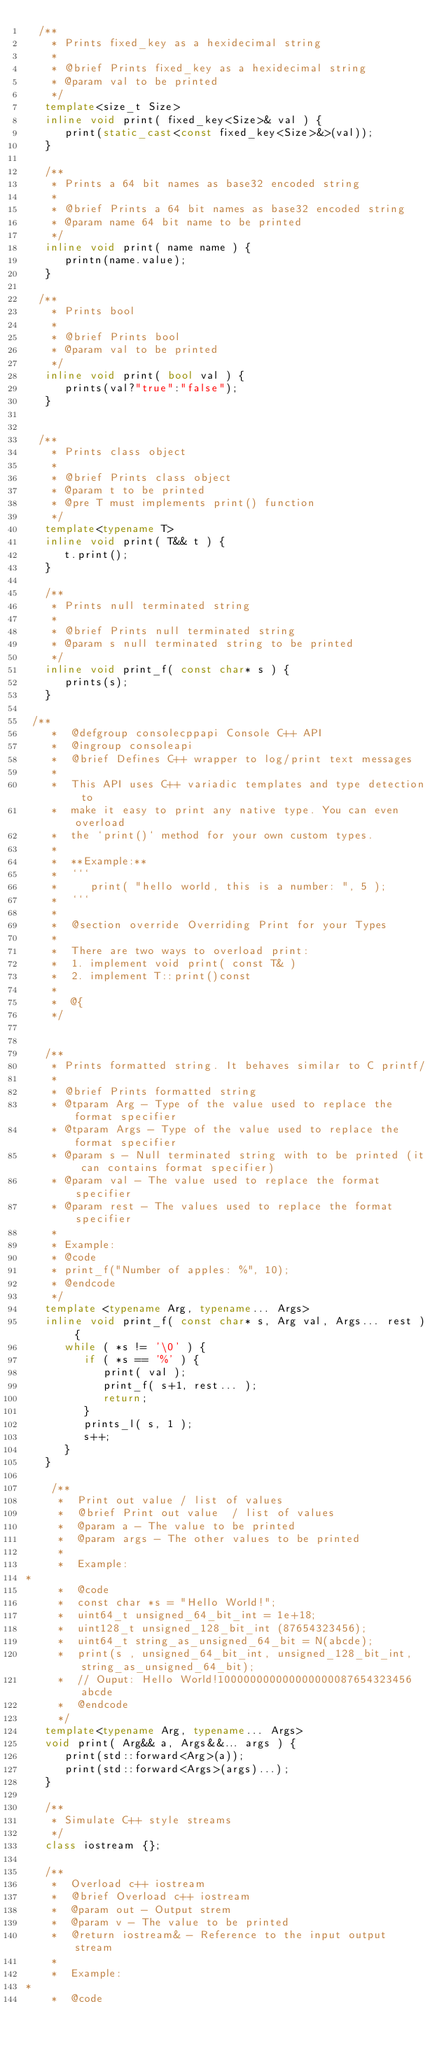Convert code to text. <code><loc_0><loc_0><loc_500><loc_500><_C++_>  /**
    * Prints fixed_key as a hexidecimal string
    * 
    * @brief Prints fixed_key as a hexidecimal string
    * @param val to be printed
    */
   template<size_t Size>
   inline void print( fixed_key<Size>& val ) {
      print(static_cast<const fixed_key<Size>&>(val));
   }

   /**
    * Prints a 64 bit names as base32 encoded string
    * 
    * @brief Prints a 64 bit names as base32 encoded string
    * @param name 64 bit name to be printed
    */
   inline void print( name name ) {
      printn(name.value);
   }

  /**
    * Prints bool
    * 
    * @brief Prints bool
    * @param val to be printed
    */
   inline void print( bool val ) {
      prints(val?"true":"false");
   }


  /**
    * Prints class object
    * 
    * @brief Prints class object
    * @param t to be printed
    * @pre T must implements print() function
    */
   template<typename T>
   inline void print( T&& t ) {
      t.print();
   }

   /**
    * Prints null terminated string
    * 
    * @brief Prints null terminated string
    * @param s null terminated string to be printed
    */
   inline void print_f( const char* s ) {
      prints(s);
   }

 /**
    *  @defgroup consolecppapi Console C++ API
    *  @ingroup consoleapi
    *  @brief Defines C++ wrapper to log/print text messages
    *
    *  This API uses C++ variadic templates and type detection to
    *  make it easy to print any native type. You can even overload
    *  the `print()` method for your own custom types.
    *
    *  **Example:**
    *  ```
    *     print( "hello world, this is a number: ", 5 );
    *  ```
    *
    *  @section override Overriding Print for your Types
    *
    *  There are two ways to overload print:
    *  1. implement void print( const T& )
    *  2. implement T::print()const
    *
    *  @{
    */


   /**
    * Prints formatted string. It behaves similar to C printf/
    * 
    * @brief Prints formatted string
    * @tparam Arg - Type of the value used to replace the format specifier
    * @tparam Args - Type of the value used to replace the format specifier
    * @param s - Null terminated string with to be printed (it can contains format specifier)
    * @param val - The value used to replace the format specifier
    * @param rest - The values used to replace the format specifier
    * 
    * Example:
    * @code
    * print_f("Number of apples: %", 10);
    * @endcode
    */
   template <typename Arg, typename... Args>
   inline void print_f( const char* s, Arg val, Args... rest ) {
      while ( *s != '\0' ) {
         if ( *s == '%' ) {
            print( val );
            print_f( s+1, rest... );
            return;
         }
         prints_l( s, 1 );
         s++;
      }
   }

    /**
     *  Print out value / list of values 
     *  @brief Print out value  / list of values
     *  @param a - The value to be printed
     *  @param args - The other values to be printed
     *
     *  Example:
*
     *  @code
     *  const char *s = "Hello World!";
     *  uint64_t unsigned_64_bit_int = 1e+18;
     *  uint128_t unsigned_128_bit_int (87654323456);
     *  uint64_t string_as_unsigned_64_bit = N(abcde);
     *  print(s , unsigned_64_bit_int, unsigned_128_bit_int, string_as_unsigned_64_bit);
     *  // Ouput: Hello World!100000000000000000087654323456abcde
     *  @endcode
     */
   template<typename Arg, typename... Args>
   void print( Arg&& a, Args&&... args ) {
      print(std::forward<Arg>(a));
      print(std::forward<Args>(args)...);
   }

   /**
    * Simulate C++ style streams
    */
   class iostream {};

   /**
    *  Overload c++ iostream
    *  @brief Overload c++ iostream
    *  @param out - Output strem
    *  @param v - The value to be printed
    *  @return iostream& - Reference to the input output stream
    *
    *  Example:
*
    *  @code</code> 